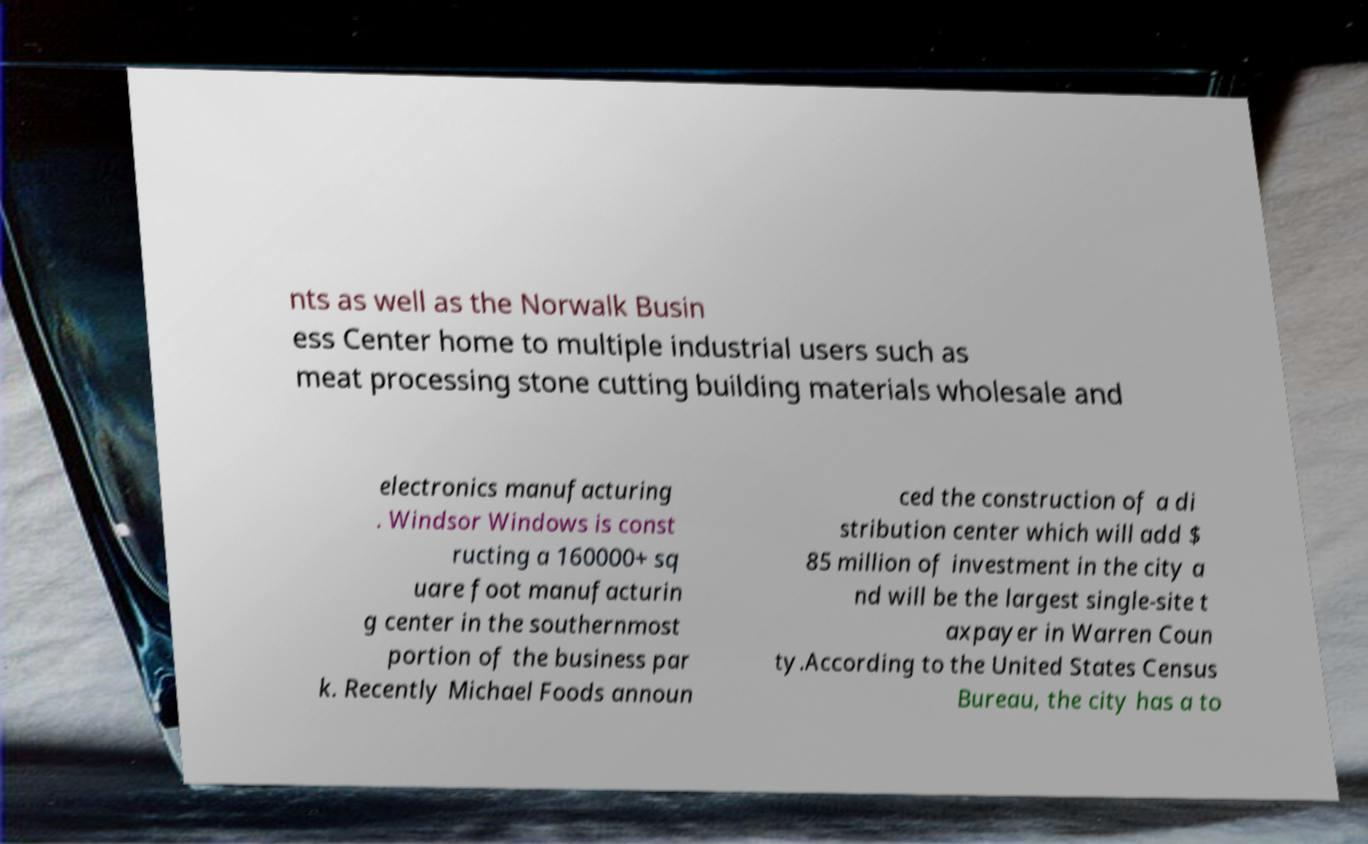I need the written content from this picture converted into text. Can you do that? nts as well as the Norwalk Busin ess Center home to multiple industrial users such as meat processing stone cutting building materials wholesale and electronics manufacturing . Windsor Windows is const ructing a 160000+ sq uare foot manufacturin g center in the southernmost portion of the business par k. Recently Michael Foods announ ced the construction of a di stribution center which will add $ 85 million of investment in the city a nd will be the largest single-site t axpayer in Warren Coun ty.According to the United States Census Bureau, the city has a to 